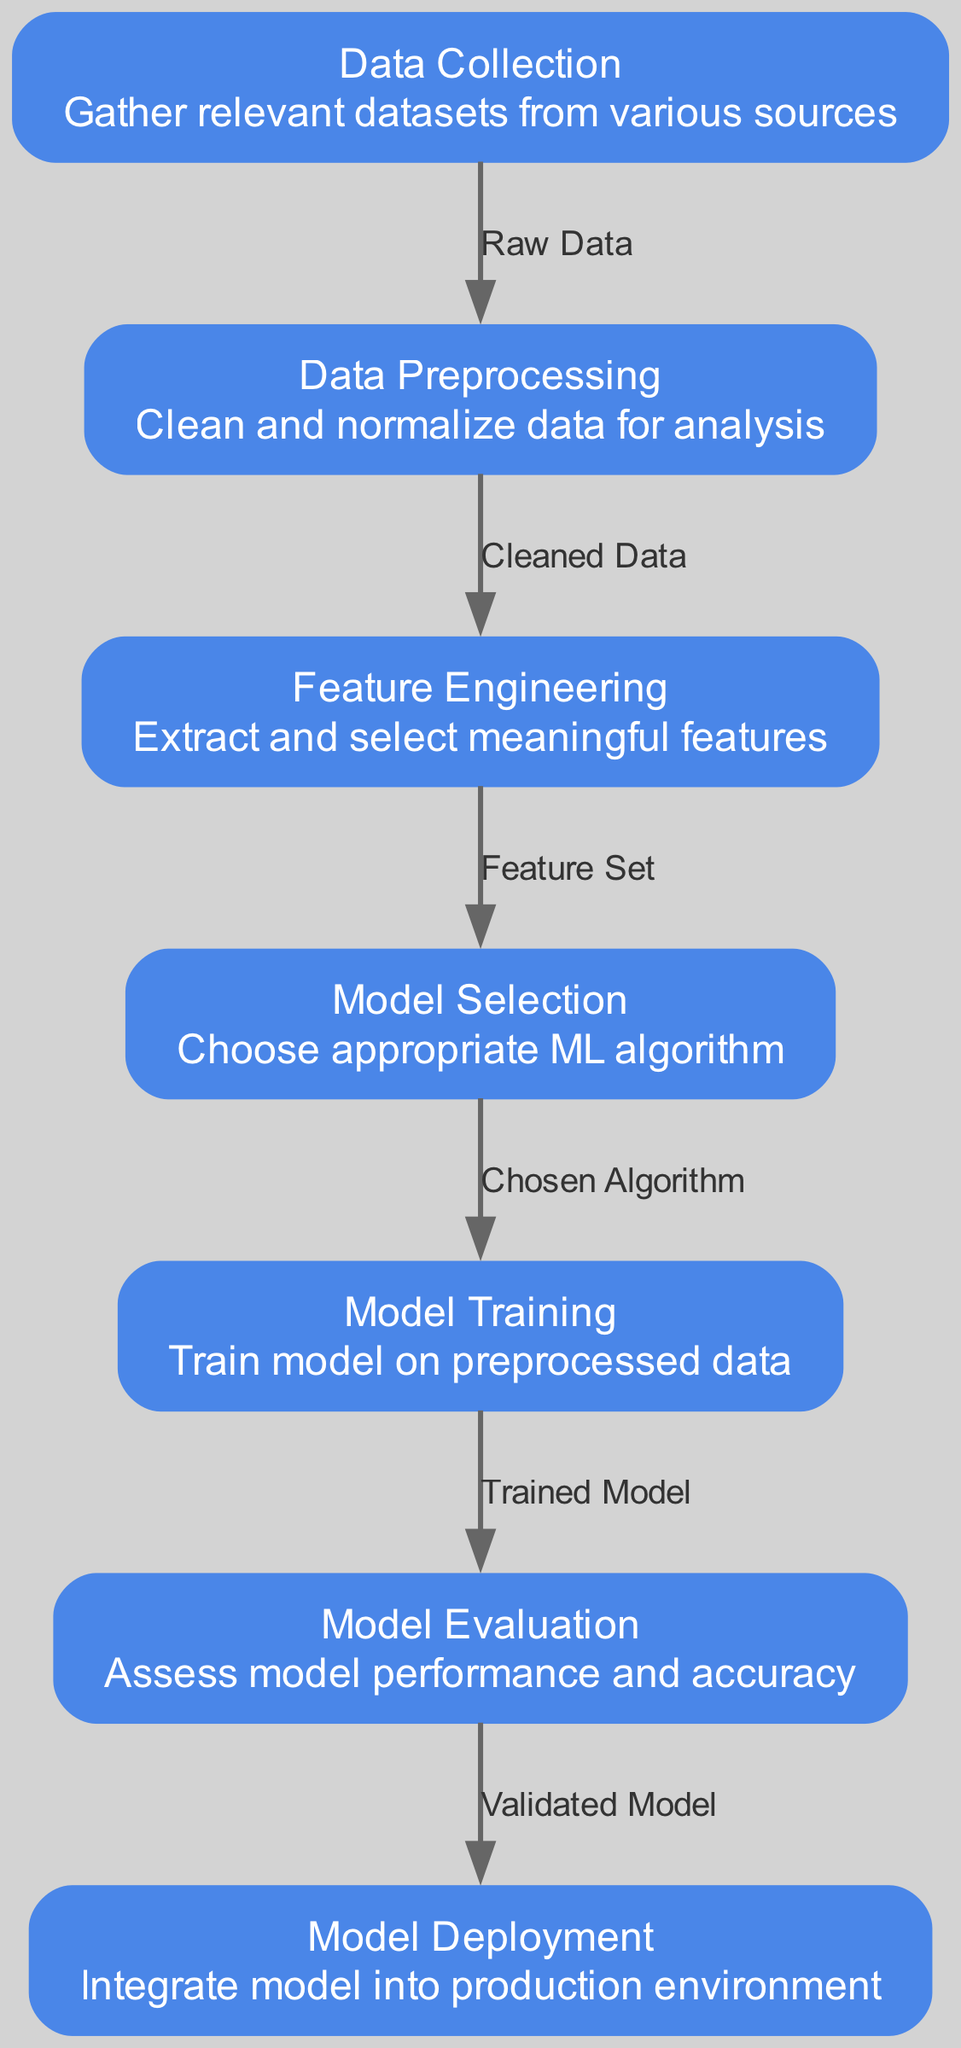What is the first step in the machine learning pipeline? The first step described in the diagram is "Data Collection", which involves gathering relevant datasets.
Answer: Data Collection How many nodes are present in the diagram? The diagram lists seven distinct nodes that represent different stages of the machine learning pipeline.
Answer: 7 What is the connection label from data preprocessing to feature engineering? The diagram indicates that the connection from "Data Preprocessing" to "Feature Engineering" is labeled "Cleaned Data".
Answer: Cleaned Data Which node follows "Model Evaluation"? According to the diagram, "Model Evaluation" is followed by "Model Deployment", indicating the next step in the pipeline.
Answer: Model Deployment What type of data is considered for "Model Training"? The diagram specifies that "Model Training" is conducted on "Preprocessed Data", which means the data has already been cleaned and prepared.
Answer: Preprocessed Data Which node is connected to "Model Selection"? The flowchart shows that "Feature Engineering" connects directly to "Model Selection", depicting the order of actions in the pipeline.
Answer: Feature Engineering How many edges are represented in the diagram? The diagram illustrates six edges that connect the various stages of the machine learning process.
Answer: 6 What is the purpose of the "Feature Engineering" node? The diagram states that "Feature Engineering" involves "Extract and select meaningful features", indicating its role in preparing the data for model selection.
Answer: Extract and select meaningful features What is the final output of this machine learning pipeline? The last node in the diagram, "Model Deployment", serves as the final step in the illustrated pipeline, indicating the integration of the model into a production environment.
Answer: Model Deployment 